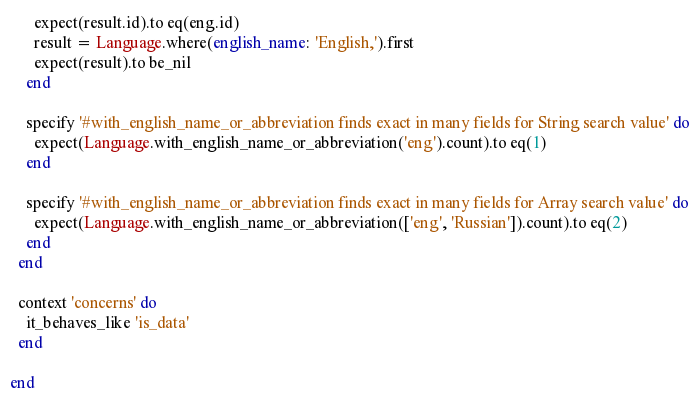<code> <loc_0><loc_0><loc_500><loc_500><_Ruby_>      expect(result.id).to eq(eng.id)
      result = Language.where(english_name: 'English,').first
      expect(result).to be_nil
    end

    specify '#with_english_name_or_abbreviation finds exact in many fields for String search value' do
      expect(Language.with_english_name_or_abbreviation('eng').count).to eq(1)
    end

    specify '#with_english_name_or_abbreviation finds exact in many fields for Array search value' do
      expect(Language.with_english_name_or_abbreviation(['eng', 'Russian']).count).to eq(2)
    end
  end

  context 'concerns' do
    it_behaves_like 'is_data'
  end

end
</code> 